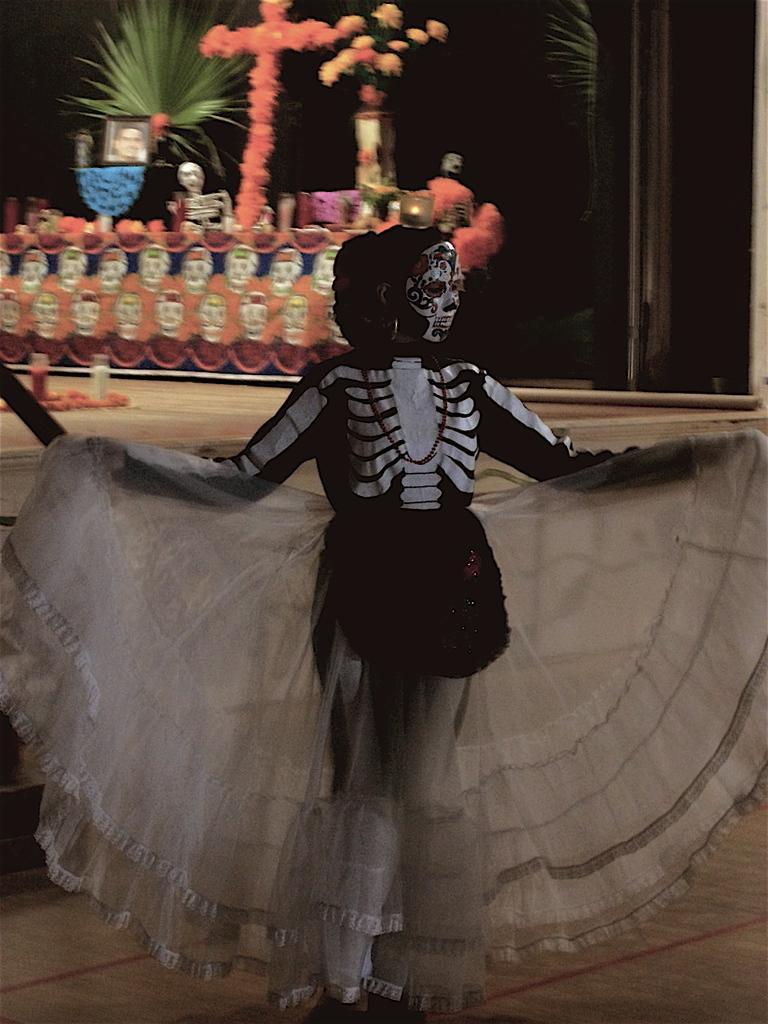Describe this image in one or two sentences. In this image in the front there is a person wearing costume. In the background there are plants and flowers and there are objects. 